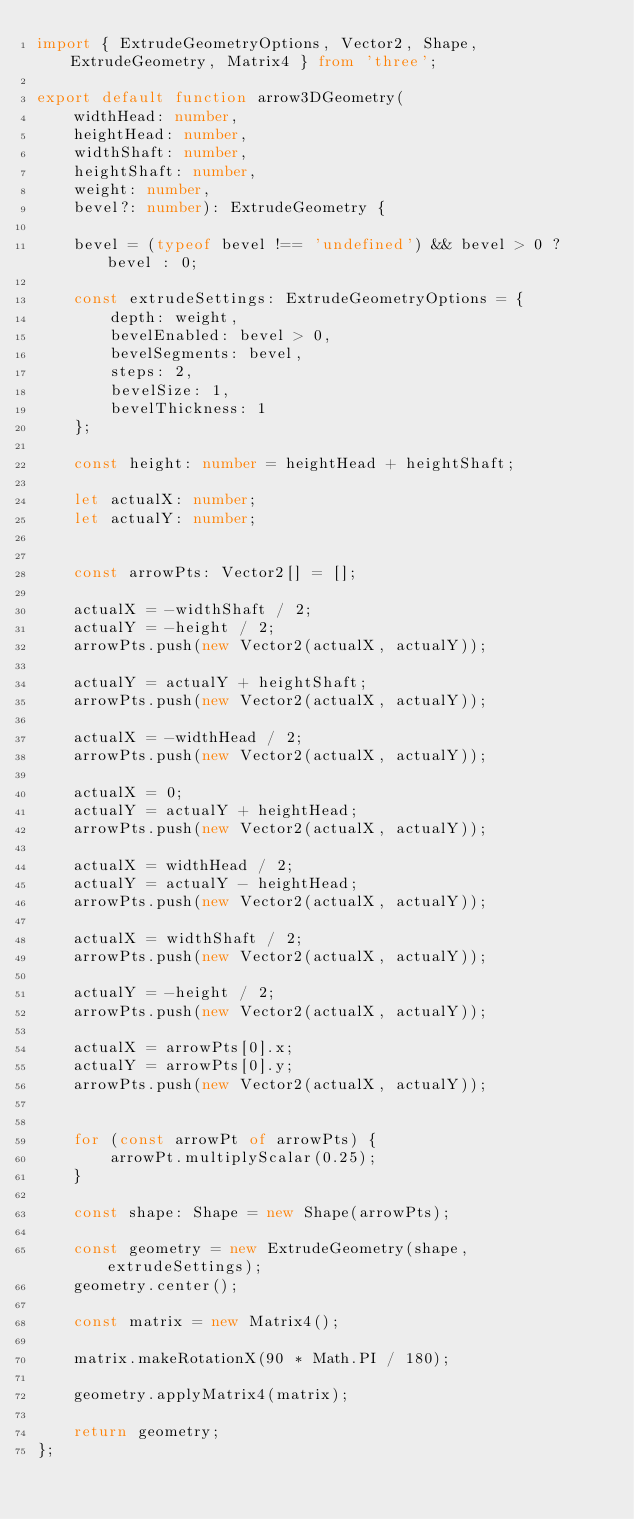<code> <loc_0><loc_0><loc_500><loc_500><_TypeScript_>import { ExtrudeGeometryOptions, Vector2, Shape, ExtrudeGeometry, Matrix4 } from 'three';

export default function arrow3DGeometry(
    widthHead: number,
    heightHead: number,
    widthShaft: number,
    heightShaft: number,
    weight: number,
    bevel?: number): ExtrudeGeometry {

    bevel = (typeof bevel !== 'undefined') && bevel > 0 ? bevel : 0;

    const extrudeSettings: ExtrudeGeometryOptions = {
        depth: weight,
        bevelEnabled: bevel > 0,
        bevelSegments: bevel,
        steps: 2,
        bevelSize: 1,
        bevelThickness: 1
    };

    const height: number = heightHead + heightShaft;

    let actualX: number;
    let actualY: number;


    const arrowPts: Vector2[] = [];

    actualX = -widthShaft / 2;
    actualY = -height / 2;
    arrowPts.push(new Vector2(actualX, actualY));

    actualY = actualY + heightShaft;
    arrowPts.push(new Vector2(actualX, actualY));

    actualX = -widthHead / 2;
    arrowPts.push(new Vector2(actualX, actualY));

    actualX = 0;
    actualY = actualY + heightHead;
    arrowPts.push(new Vector2(actualX, actualY));

    actualX = widthHead / 2;
    actualY = actualY - heightHead;
    arrowPts.push(new Vector2(actualX, actualY));

    actualX = widthShaft / 2;
    arrowPts.push(new Vector2(actualX, actualY));

    actualY = -height / 2;
    arrowPts.push(new Vector2(actualX, actualY));

    actualX = arrowPts[0].x;
    actualY = arrowPts[0].y;
    arrowPts.push(new Vector2(actualX, actualY));


    for (const arrowPt of arrowPts) {
        arrowPt.multiplyScalar(0.25);
    }

    const shape: Shape = new Shape(arrowPts);

    const geometry = new ExtrudeGeometry(shape, extrudeSettings);
    geometry.center();

    const matrix = new Matrix4();

    matrix.makeRotationX(90 * Math.PI / 180);

    geometry.applyMatrix4(matrix);

    return geometry;
};</code> 